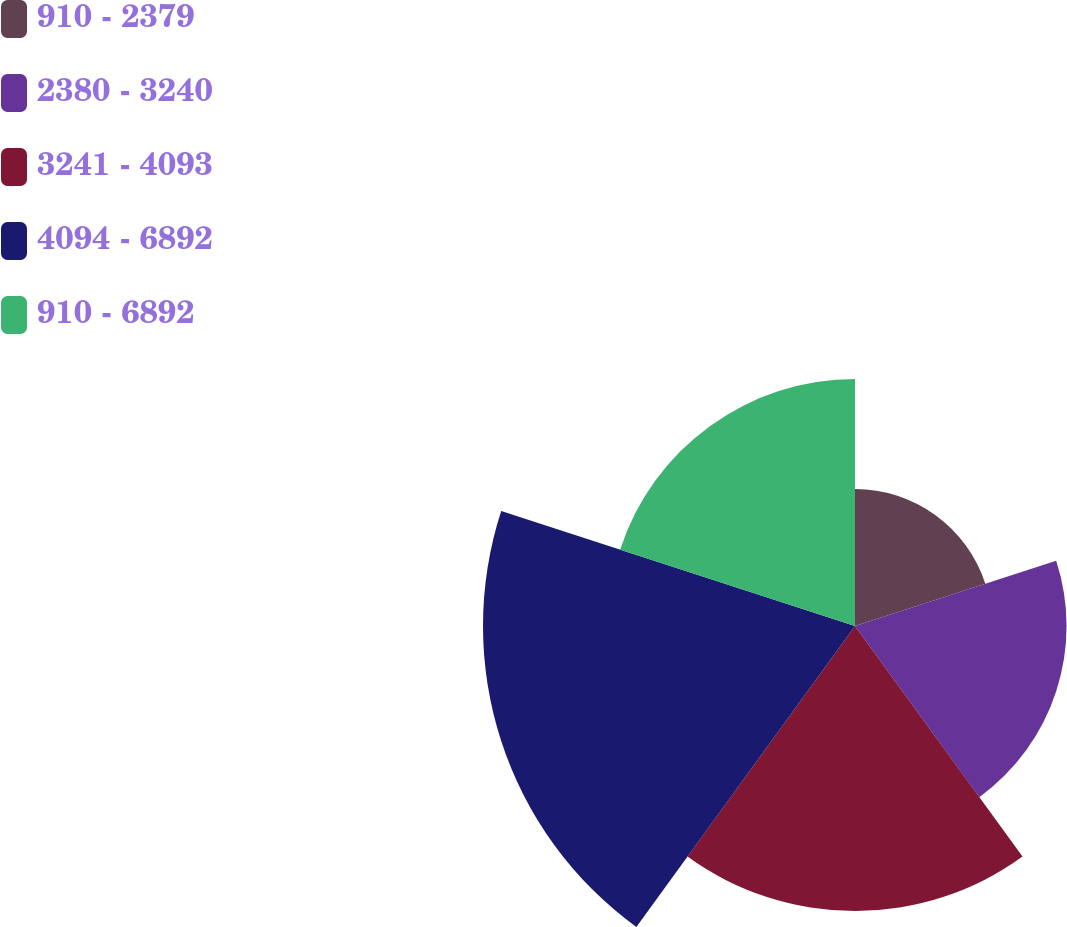Convert chart. <chart><loc_0><loc_0><loc_500><loc_500><pie_chart><fcel>910 - 2379<fcel>2380 - 3240<fcel>3241 - 4093<fcel>4094 - 6892<fcel>910 - 6892<nl><fcel>10.94%<fcel>16.89%<fcel>22.75%<fcel>29.7%<fcel>19.72%<nl></chart> 